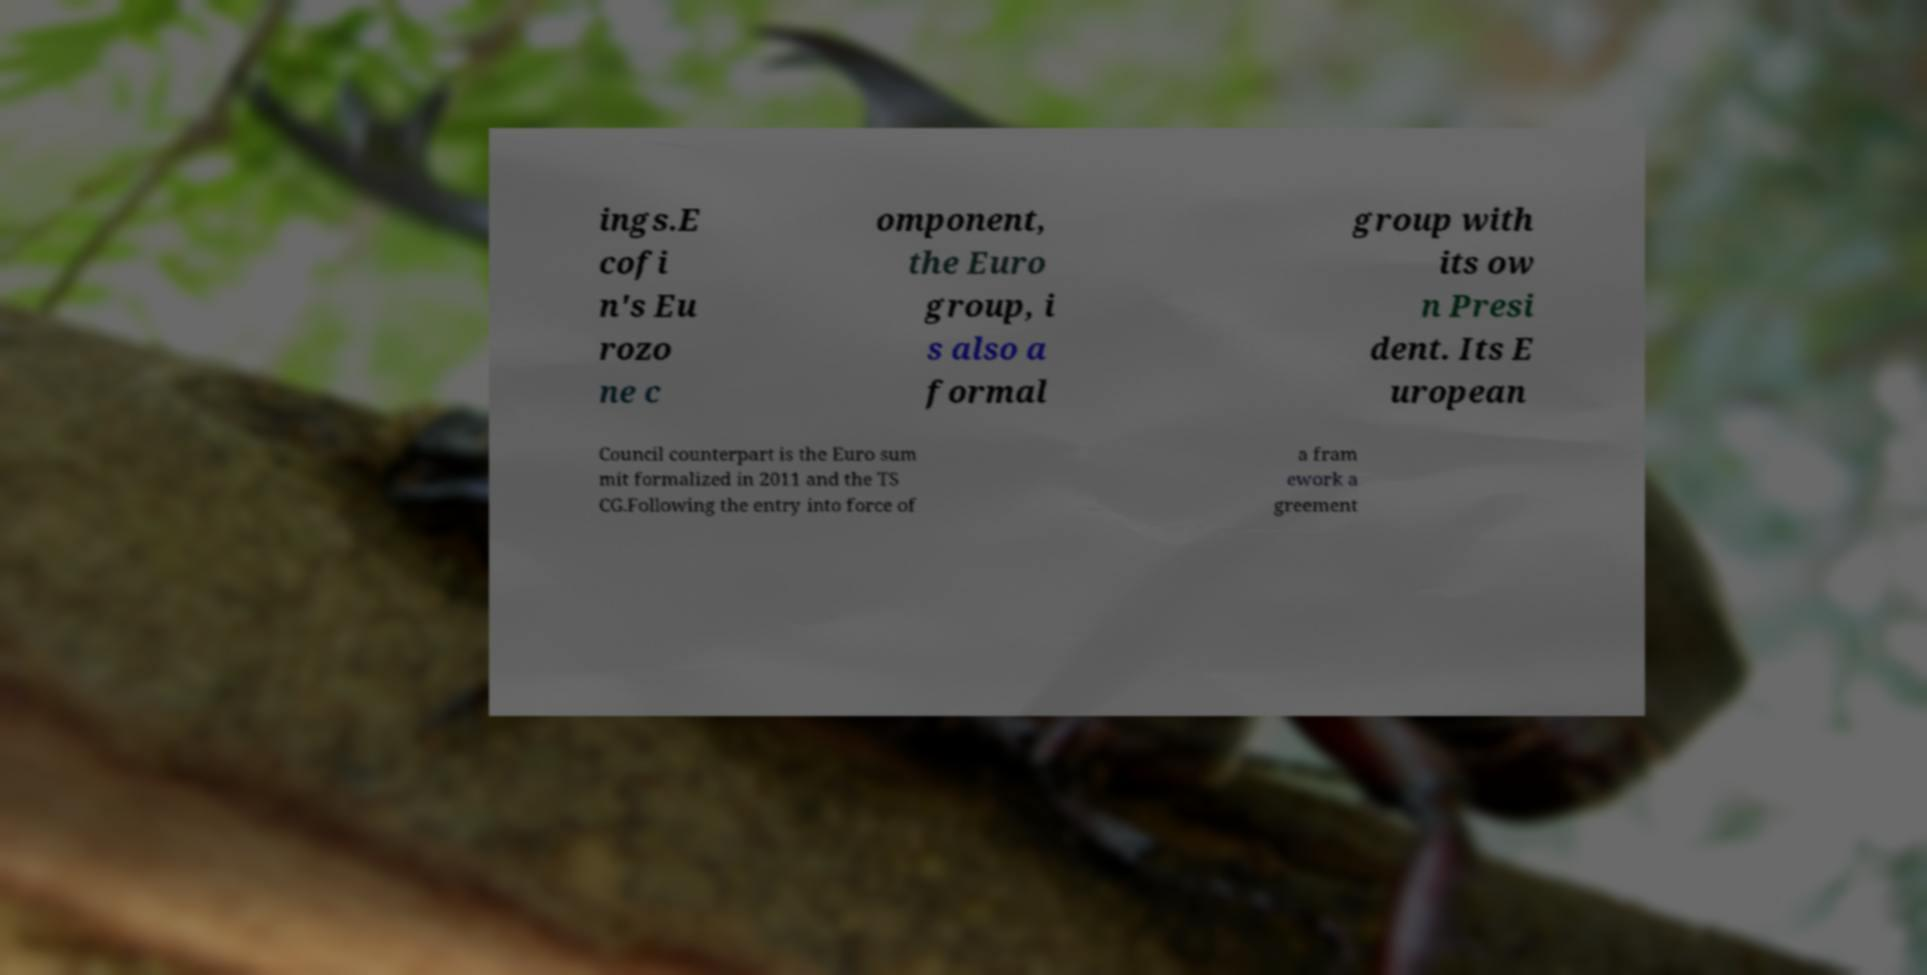Can you read and provide the text displayed in the image?This photo seems to have some interesting text. Can you extract and type it out for me? ings.E cofi n's Eu rozo ne c omponent, the Euro group, i s also a formal group with its ow n Presi dent. Its E uropean Council counterpart is the Euro sum mit formalized in 2011 and the TS CG.Following the entry into force of a fram ework a greement 